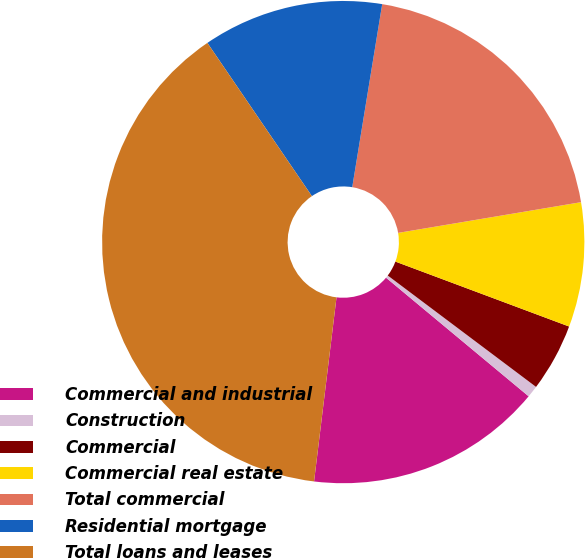Convert chart to OTSL. <chart><loc_0><loc_0><loc_500><loc_500><pie_chart><fcel>Commercial and industrial<fcel>Construction<fcel>Commercial<fcel>Commercial real estate<fcel>Total commercial<fcel>Residential mortgage<fcel>Total loans and leases<nl><fcel>15.89%<fcel>0.79%<fcel>4.56%<fcel>8.34%<fcel>19.77%<fcel>12.11%<fcel>38.54%<nl></chart> 